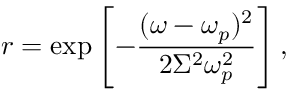Convert formula to latex. <formula><loc_0><loc_0><loc_500><loc_500>r = \exp \left [ - \frac { ( \omega - \omega _ { p } ) ^ { 2 } } { 2 \Sigma ^ { 2 } \omega _ { p } ^ { 2 } } \right ] ,</formula> 